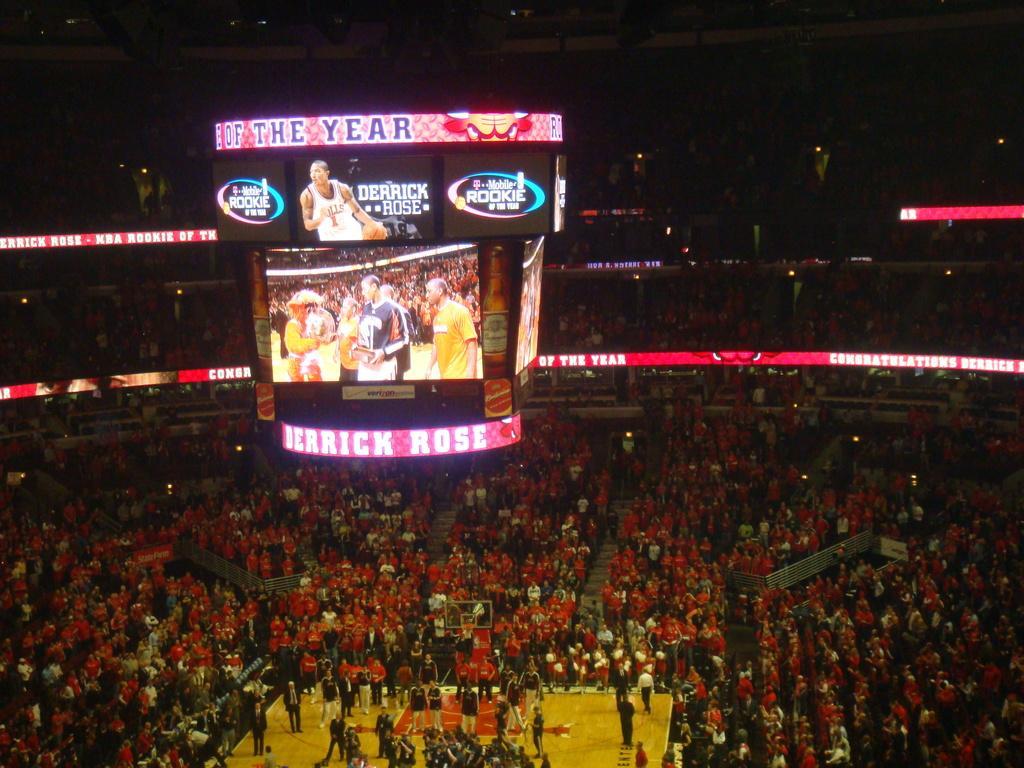Can you describe this image briefly? In this image in the front of there are group of persons standing. In the center there are boards and there are monitors with some text and images on it and there are lights in the background. 